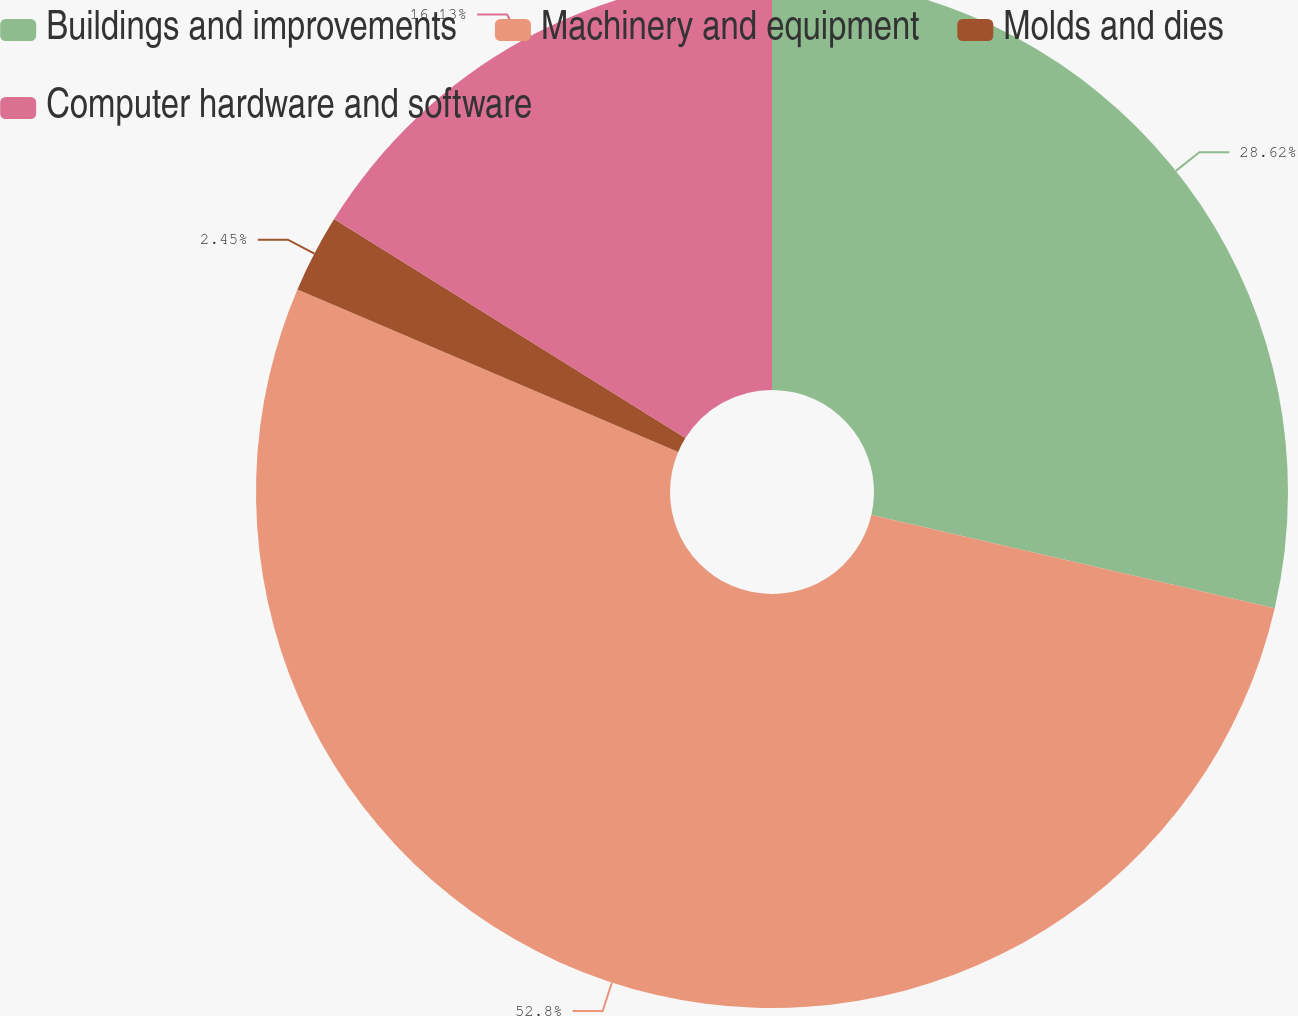Convert chart. <chart><loc_0><loc_0><loc_500><loc_500><pie_chart><fcel>Buildings and improvements<fcel>Machinery and equipment<fcel>Molds and dies<fcel>Computer hardware and software<nl><fcel>28.62%<fcel>52.81%<fcel>2.45%<fcel>16.13%<nl></chart> 